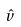<formula> <loc_0><loc_0><loc_500><loc_500>\hat { v }</formula> 